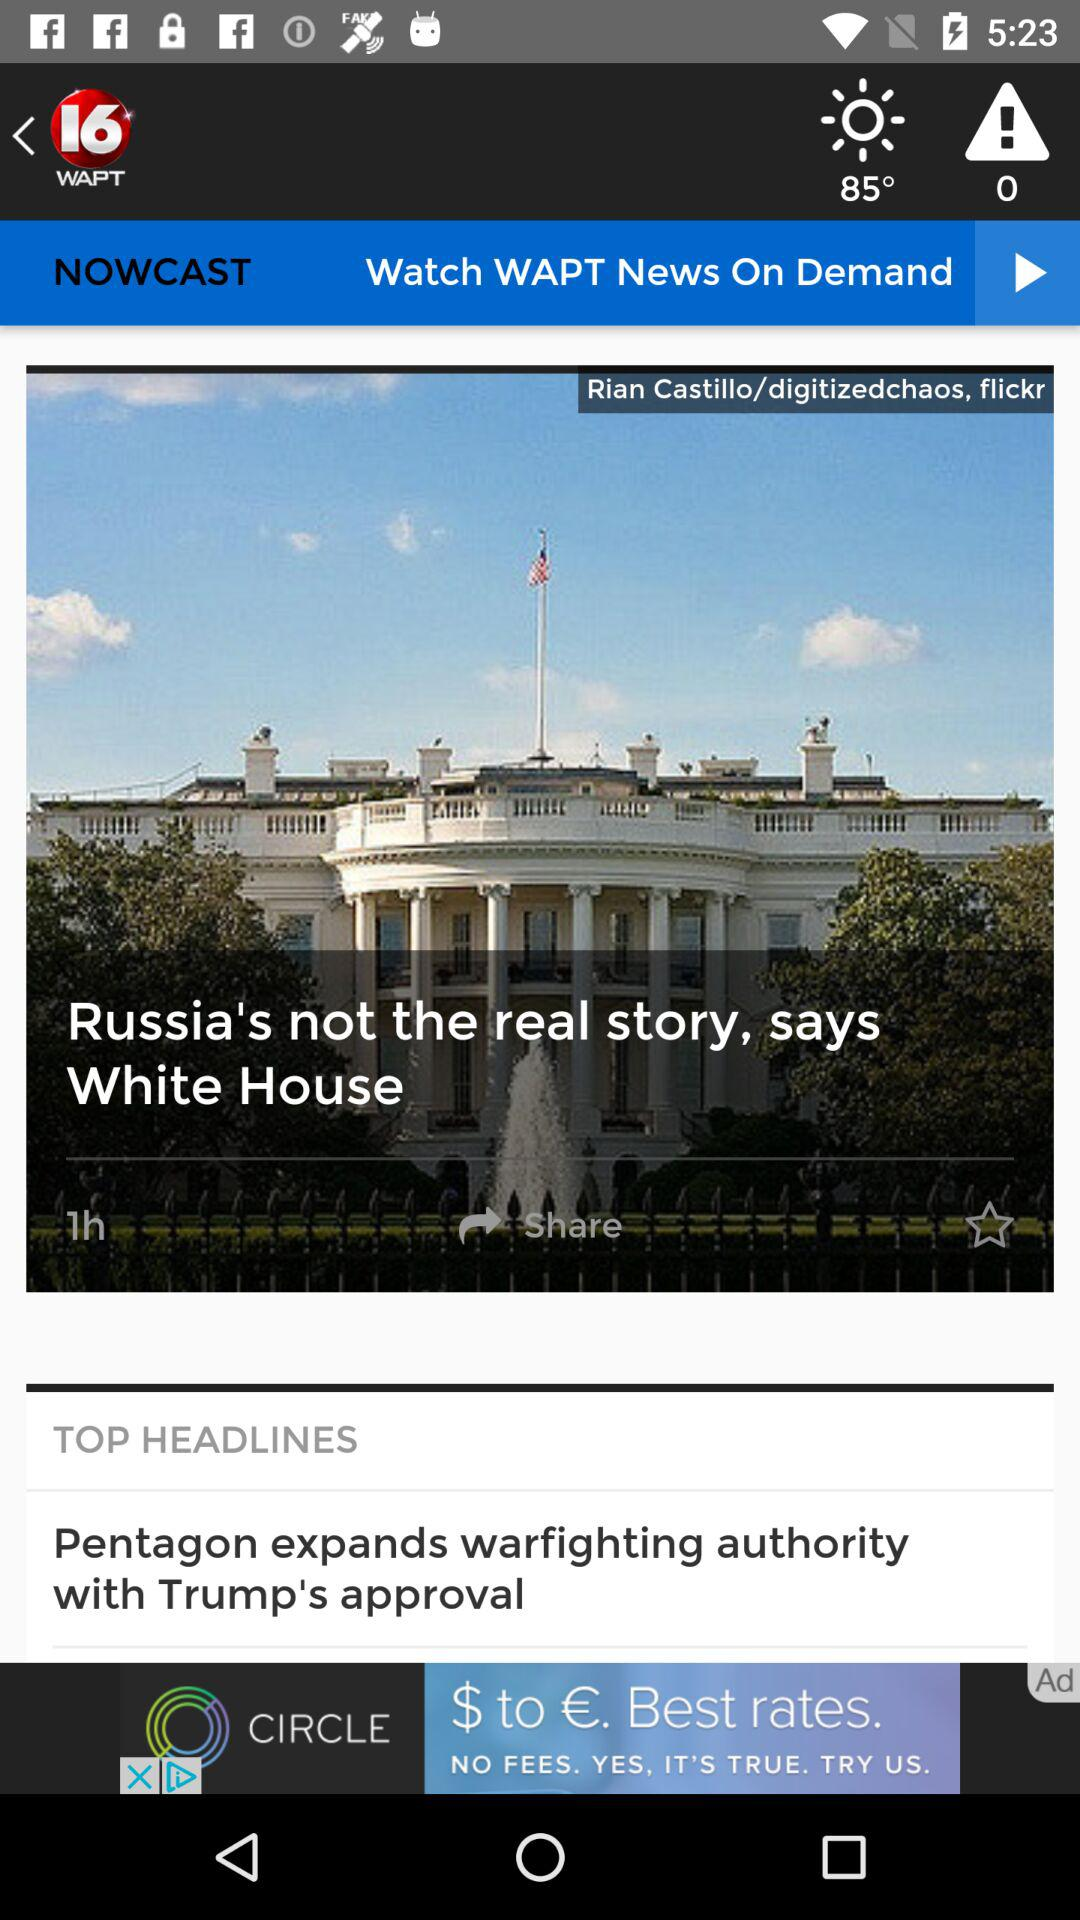When was the post updated? The post was updated 1 hour ago. 